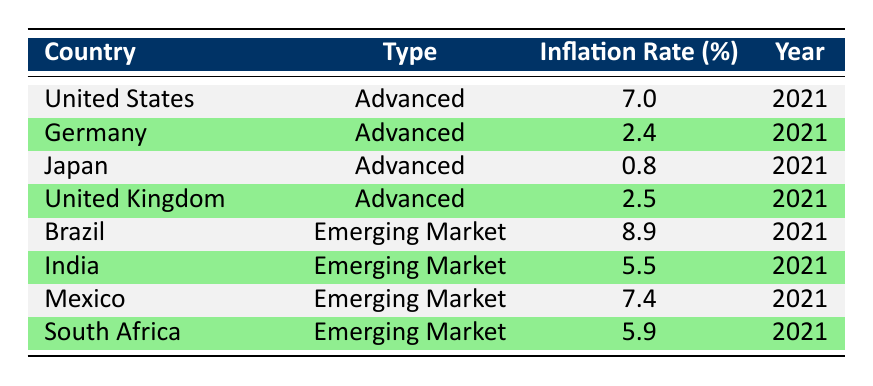What is the inflation rate in the United States in 2021? The table shows that the inflation rate for the United States in 2021 is listed as 7.0%.
Answer: 7.0% Which country had the highest inflation rate in emerging markets? By reviewing the values for emerging markets, Brazil has the highest inflation rate at 8.9%.
Answer: 8.9% What is the average inflation rate for advanced countries listed in the table? The inflation rates for advanced countries are 7.0 (US), 2.4 (Germany), 0.8 (Japan), and 2.5 (UK). The sum is 12.7, and there are 4 countries, so the average is 12.7 / 4 = 3.175%.
Answer: 3.175% Was the inflation rate in South Africa higher than that in India? The inflation rate for South Africa is 5.9%, and for India, it is 5.5%. Since 5.9% is greater than 5.5%, the statement is true.
Answer: Yes How much higher is Brazil's inflation rate compared to Japan's? Brazil's inflation rate is 8.9%, and Japan's is 0.8%. To find the difference, subtract: 8.9 - 0.8 = 8.1.
Answer: 8.1 Is the average inflation rate of emerging markets less than 6%? The inflation rates for emerging markets are 8.9 (Brazil), 5.5 (India), 7.4 (Mexico), and 5.9 (South Africa). The sum is 28.7, and there are 4 countries, thus the average is 28.7 / 4 = 7.175%, which is greater than 6%. This statement is false.
Answer: No What percent of the countries listed have an inflation rate above 5%? There are 8 countries total. The countries with inflation rates above 5% are the United States (7.0%), Brazil (8.9%), Mexico (7.4%), and South Africa (5.9%) totaling 4 countries. The percentage is (4/8) * 100 = 50%.
Answer: 50% Which country has the lowest inflation rate among advanced economies? In the table, Japan has the lowest inflation rate at 0.8% among advanced economies.
Answer: 0.8% What is the total inflation rate for all countries listed in the table? The total inflation rate is calculated by summing all values: 7.0 + 2.4 + 0.8 + 2.5 + 8.9 + 5.5 + 7.4 + 5.9 = 40.0.
Answer: 40.0 